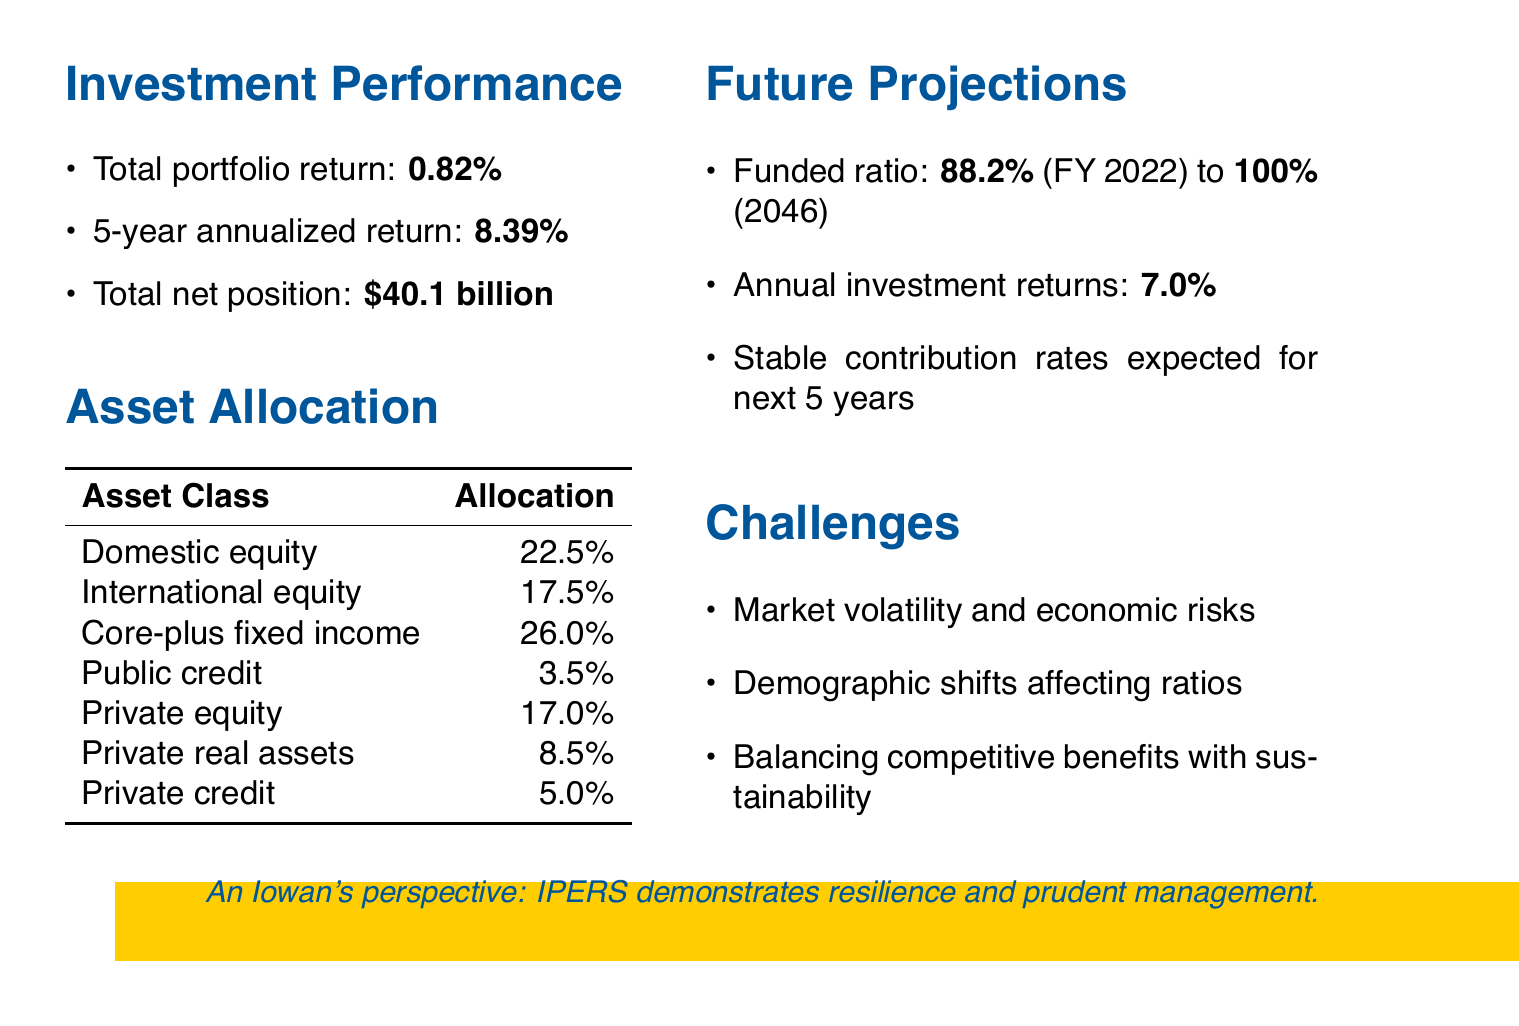What was IPERS' total portfolio return for FY 2022? The total portfolio return for FY 2022 is specifically stated in the investment performance section of the document.
Answer: 0.82% What is the projected funded ratio for IPERS by 2046? The projected funded ratio is mentioned in the future projections section, indicating the expected improvement over time.
Answer: 100% What is the total net position of IPERS as of June 30, 2022? The total net position is provided in the context of investment performance, reflecting the fund's financial status.
Answer: $40.1 billion What is the expected annual investment return rate? The expected annual investment return rate is outlined in the future projections section, indicating the stability of the assumption over time.
Answer: 7.0% What percentage of IPERS' assets is allocated to private equity? The asset allocation section provides specific percentages for various asset classes, including private equity.
Answer: 17.0% What is one of the challenges mentioned for IPERS? The document lists several challenges that IPERS faces, capturing the complexities of managing the retirement system.
Answer: Market volatility and potential economic downturn risks What was the 5-year annualized return for IPERS? This metric is a part of the investment performance analysis and reflects the fund's growth over a longer timeframe.
Answer: 8.39% What is the percentage allocation for domestic equity? The allocation percentages by asset class are provided in a table format within the asset allocation section.
Answer: 22.5% 